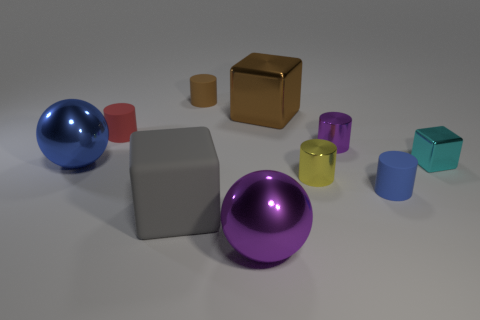Subtract all tiny cyan metallic blocks. How many blocks are left? 2 Subtract all red cylinders. How many cylinders are left? 4 Subtract all brown cylinders. Subtract all gray balls. How many cylinders are left? 4 Subtract all cubes. How many objects are left? 7 Subtract all gray things. Subtract all purple cylinders. How many objects are left? 8 Add 5 cylinders. How many cylinders are left? 10 Add 6 small red rubber cylinders. How many small red rubber cylinders exist? 7 Subtract 0 green cylinders. How many objects are left? 10 